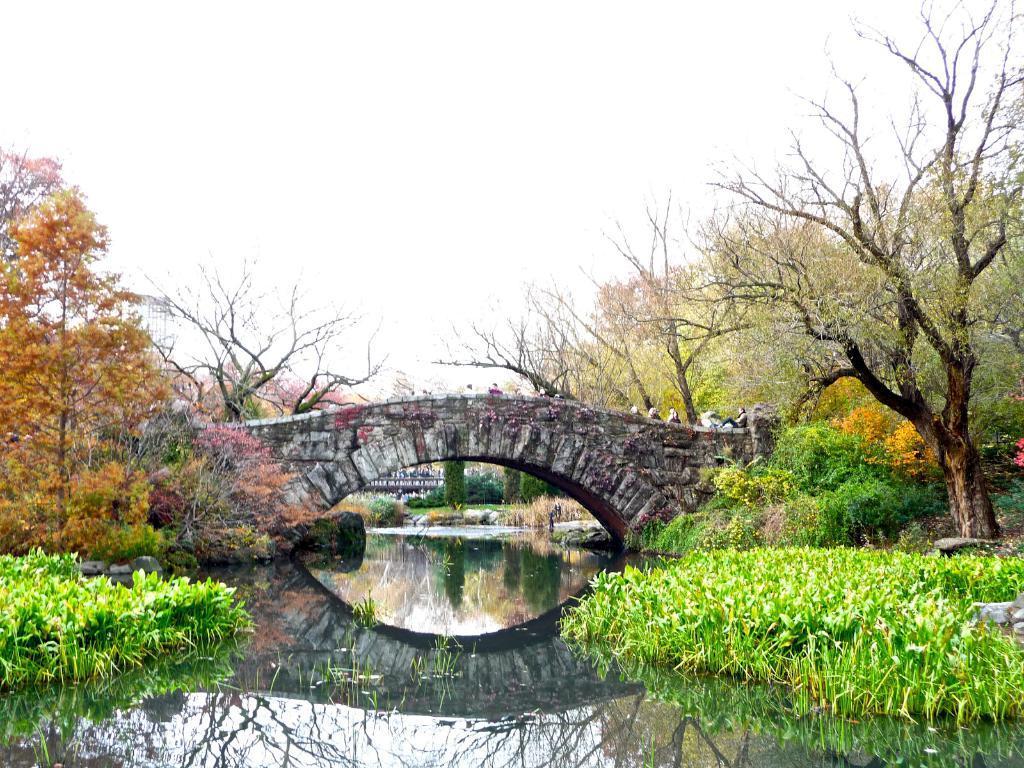Please provide a concise description of this image. In this picture I can see trees and a bridge and water and few plants in the water and few people standing on the bridge and i can see another bridge on the back and a cloudy Sky. 